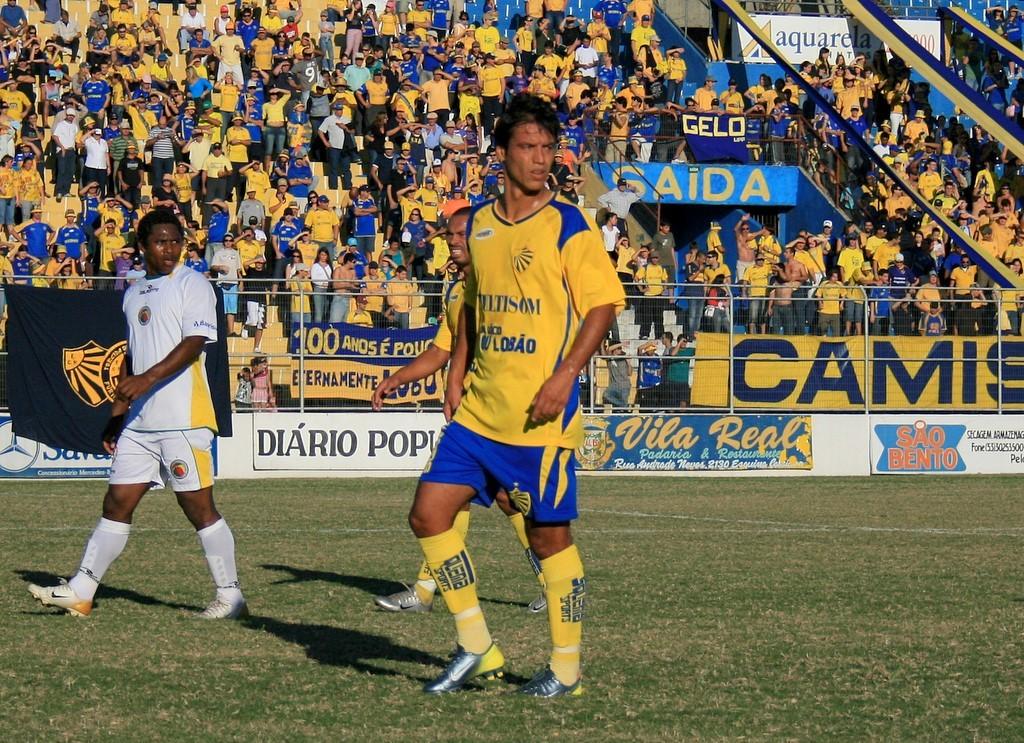What does the big blue sign in the crowd say?
Provide a short and direct response. Gaida. 